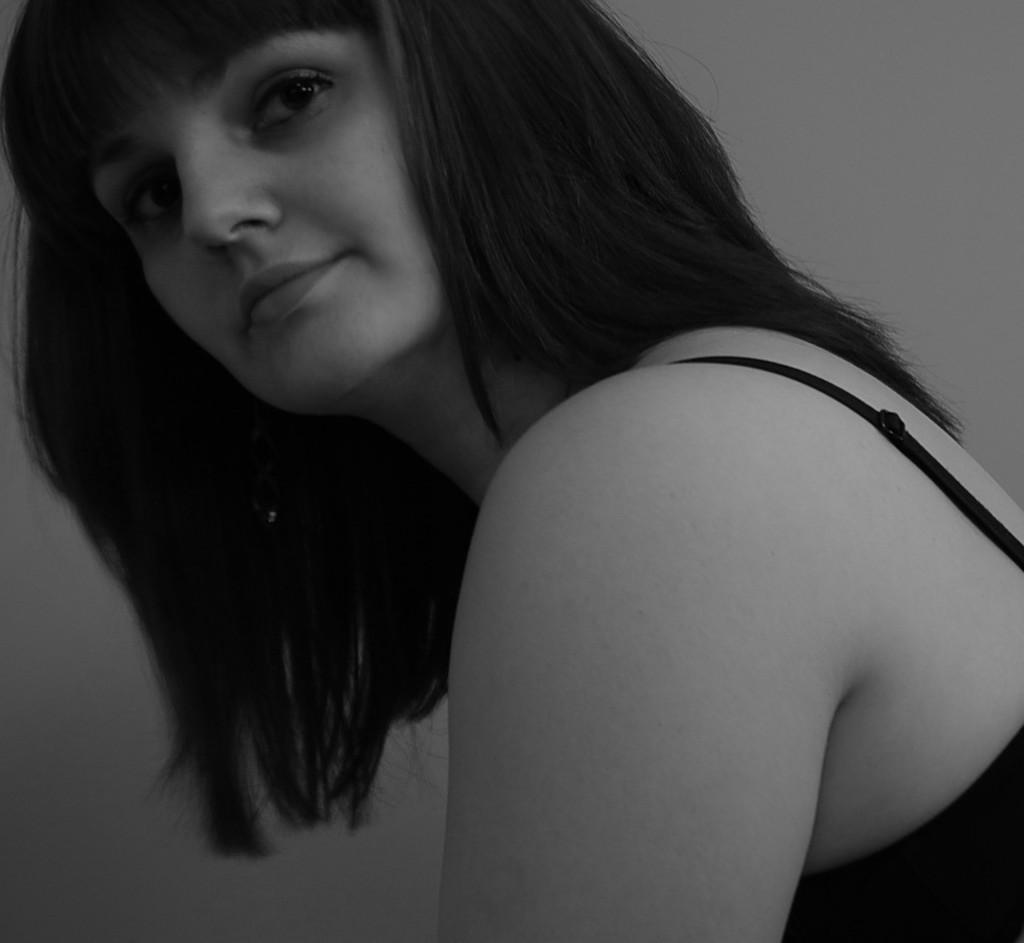Who is present in the image? There is a woman in the image. What is the woman wearing? The woman is wearing a black dress. What can be seen behind the woman? There is a wall visible behind the woman. What type of frog can be seen sitting on the woman's chin in the image? There is no frog present in the image, and the woman's chin is not visible. 